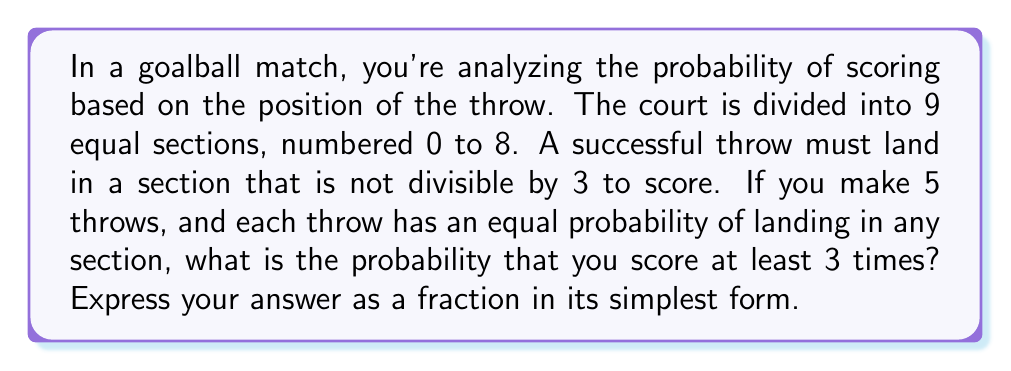Help me with this question. Let's approach this step-by-step using modular arithmetic and probability theory:

1) First, we need to determine which sections result in a score. Using modular arithmetic:
   Sections not divisible by 3: 1, 2, 4, 5, 7, 8
   Sections divisible by 3: 0, 3, 6

2) The probability of scoring on a single throw is:
   $P(\text{score}) = \frac{6}{9} = \frac{2}{3}$

3) The probability of not scoring is:
   $P(\text{no score}) = 1 - P(\text{score}) = \frac{1}{3}$

4) We want the probability of scoring at least 3 times out of 5 throws. This can happen in three ways:
   - Scoring 3 times and not scoring 2 times
   - Scoring 4 times and not scoring 1 time
   - Scoring 5 times

5) We can calculate these probabilities using the binomial probability formula:
   $P(X = k) = \binom{n}{k} p^k (1-p)^{n-k}$
   where $n$ is the number of trials, $k$ is the number of successes, $p$ is the probability of success.

6) Calculating each probability:
   $P(3\text{ scores}) = \binom{5}{3} (\frac{2}{3})^3 (\frac{1}{3})^2 = 10 \cdot \frac{8}{27} \cdot \frac{1}{9} = \frac{80}{243}$
   
   $P(4\text{ scores}) = \binom{5}{4} (\frac{2}{3})^4 (\frac{1}{3})^1 = 5 \cdot \frac{16}{81} \cdot \frac{1}{3} = \frac{80}{243}$
   
   $P(5\text{ scores}) = \binom{5}{5} (\frac{2}{3})^5 = \frac{32}{243}$

7) The total probability is the sum of these individual probabilities:
   $P(\text{at least 3 scores}) = \frac{80}{243} + \frac{80}{243} + \frac{32}{243} = \frac{192}{243}$

8) This fraction can be simplified by dividing both numerator and denominator by their greatest common divisor (3):
   $\frac{192}{243} = \frac{64}{81}$
Answer: $\frac{64}{81}$ 